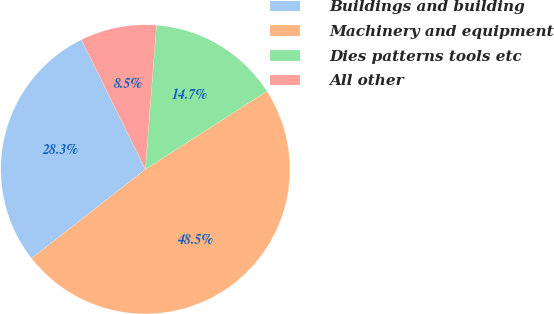Convert chart to OTSL. <chart><loc_0><loc_0><loc_500><loc_500><pie_chart><fcel>Buildings and building<fcel>Machinery and equipment<fcel>Dies patterns tools etc<fcel>All other<nl><fcel>28.29%<fcel>48.51%<fcel>14.68%<fcel>8.52%<nl></chart> 